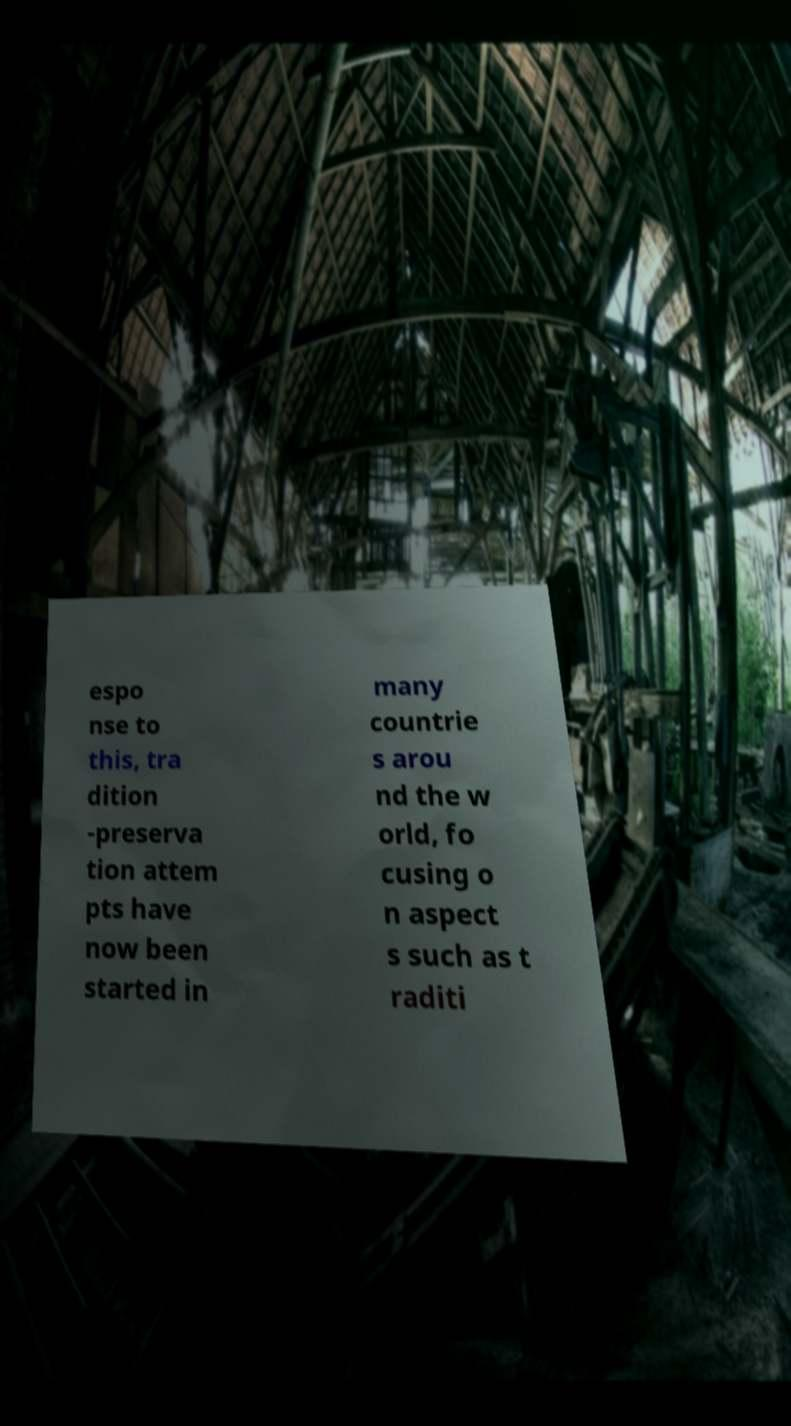I need the written content from this picture converted into text. Can you do that? espo nse to this, tra dition -preserva tion attem pts have now been started in many countrie s arou nd the w orld, fo cusing o n aspect s such as t raditi 